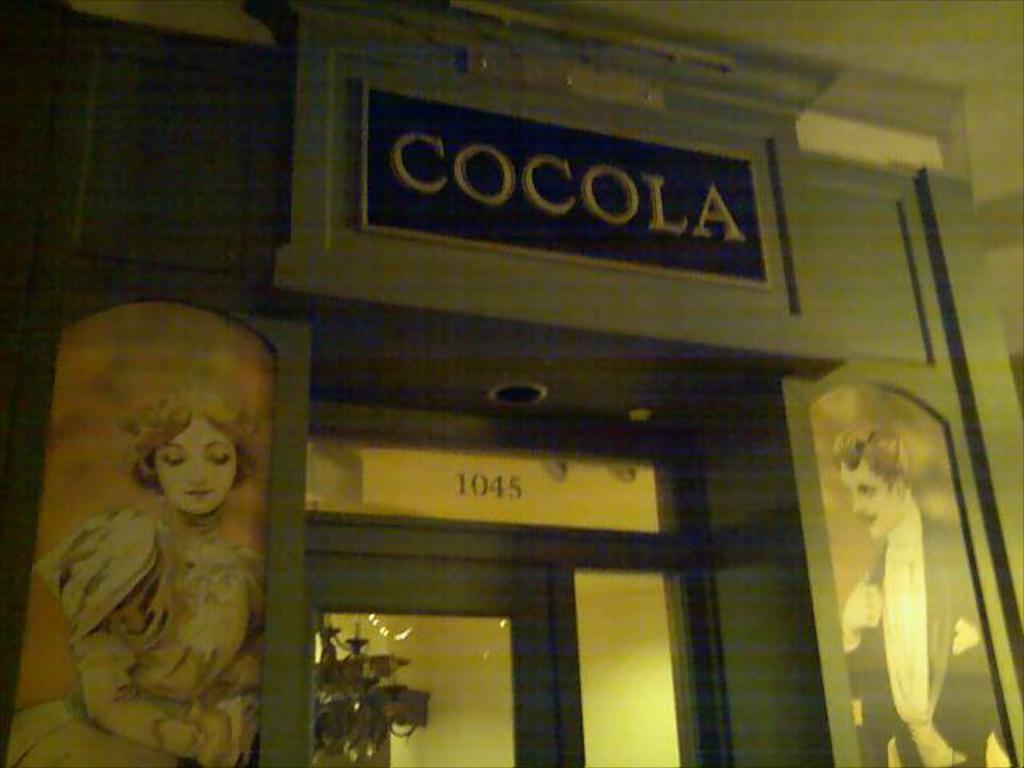In one or two sentences, can you explain what this image depicts? In this image we can see a building with some images and text on it, we can see there is a door, through the door we can see the wall and a houseplant. 